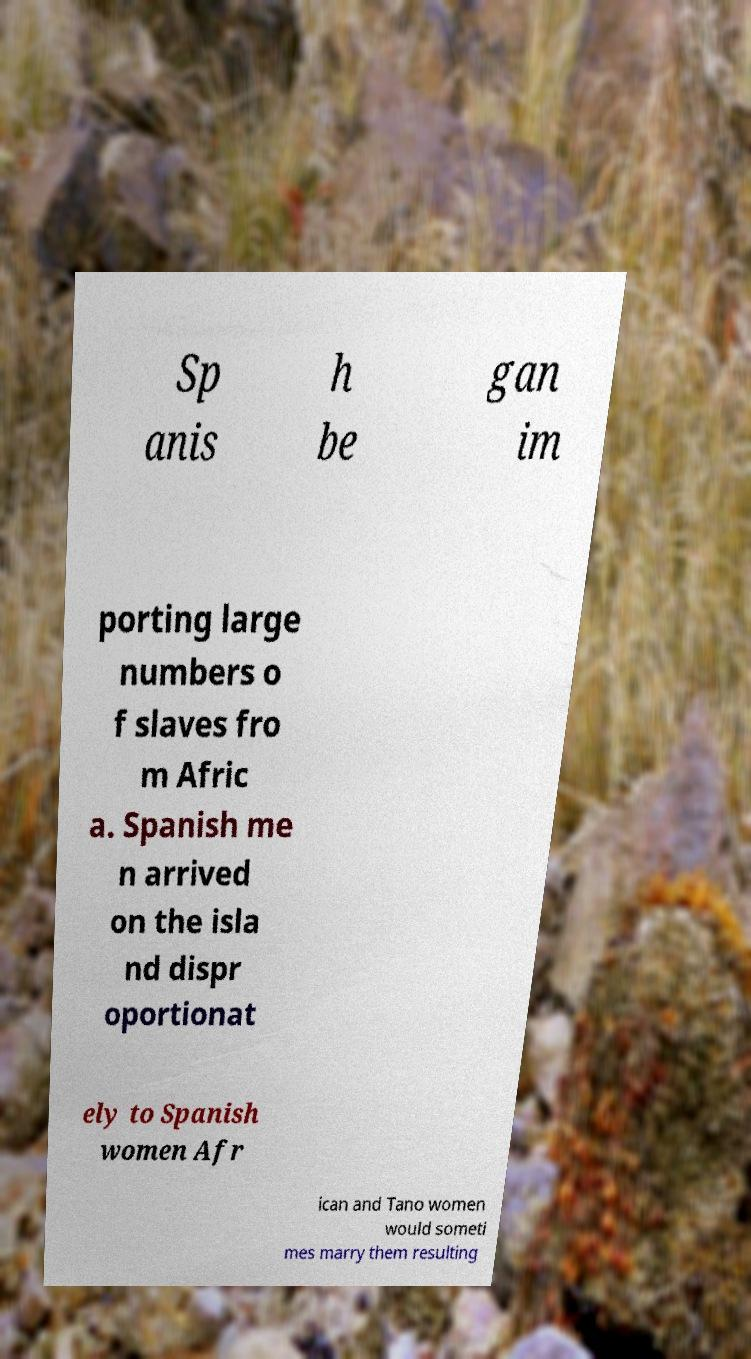Please read and relay the text visible in this image. What does it say? Sp anis h be gan im porting large numbers o f slaves fro m Afric a. Spanish me n arrived on the isla nd dispr oportionat ely to Spanish women Afr ican and Tano women would someti mes marry them resulting 